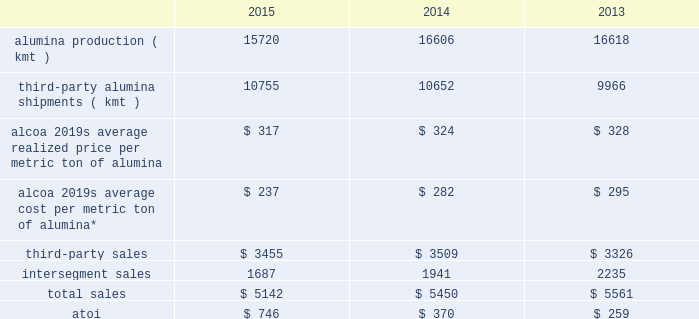Additionally , the latin american soft alloy extrusions business previously included in corporate was moved into the new transportation and construction solutions segment .
The remaining engineered products and solutions segment consists of the alcoa fastening systems and rings ( renamed to include portions of the firth rixson business acquired in november 2014 ) , alcoa power and propulsion ( includes the tital business acquired in march 2015 ) , alcoa forgings and extrusions ( includes the other portions of firth rixson ) , and alcoa titanium and engineered products ( a new business unit that consists solely of the rti international metals business acquired in july 2015 ) business units .
Segment information for all prior periods presented was updated to reflect the new segment structure .
Atoi for all reportable segments totaled $ 1906 in 2015 , $ 1968 in 2014 , and $ 1267 in 2013 .
The following information provides shipments , sales , and atoi data for each reportable segment , as well as certain production , realized price , and average cost data , for each of the three years in the period ended december 31 , 2015 .
See note q to the consolidated financial statements in part ii item 8 of this form 10-k for additional information .
Alumina .
* includes all production-related costs , including raw materials consumed ; conversion costs , such as labor , materials , and utilities ; depreciation , depletion , and amortization ; and plant administrative expenses .
This segment represents a portion of alcoa 2019s upstream operations and consists of the company 2019s worldwide refining system .
Alumina mines bauxite , from which alumina is produced and then sold directly to external smelter customers , as well as to the primary metals segment ( see primary metals below ) , or to customers who process it into industrial chemical products .
More than half of alumina 2019s production is sold under supply contracts to third parties worldwide , while the remainder is used internally by the primary metals segment .
Alumina produced by this segment and used internally is transferred to the primary metals segment at prevailing market prices .
A portion of this segment 2019s third- party sales are completed through the use of agents , alumina traders , and distributors .
Generally , the sales of this segment are transacted in u.s .
Dollars while costs and expenses of this segment are transacted in the local currency of the respective operations , which are the australian dollar , the brazilian real , the u.s .
Dollar , and the euro .
Awac is an unincorporated global joint venture between alcoa and alumina limited and consists of a number of affiliated operating entities , which own , or have an interest in , or operate the bauxite mines and alumina refineries within the alumina segment ( except for the poc 0327os de caldas refinery in brazil and a portion of the sa 0303o lul 0301s refinery in brazil ) .
Alcoa owns 60% ( 60 % ) and alumina limited owns 40% ( 40 % ) of these individual entities , which are consolidated by the company for financial reporting purposes .
As such , the results and analysis presented for the alumina segment are inclusive of alumina limited 2019s 40% ( 40 % ) interest .
In december 2014 , awac completed the sale of its ownership stake in jamalco , a bauxite mine and alumina refinery joint venture in jamaica , to noble group ltd .
Jamalco was 55% ( 55 % ) owned by a subsidiary of awac , and , while owned by awac , 55% ( 55 % ) of both the operating results and assets and liabilities of this joint venture were included in the alumina segment .
As it relates to awac 2019s previous 55% ( 55 % ) ownership stake , the refinery ( awac 2019s share of the capacity was 779 kmt-per-year ) generated sales ( third-party and intersegment ) of approximately $ 200 in 2013 , and the refinery and mine combined , at the time of divestiture , had approximately 500 employees .
See restructuring and other charges in results of operations above. .
What is the decrease in the alumina production during 2014 and 2015 , in kmt? 
Rationale: it is the variation between those two production values during 2015 and 2014 .
Computations: (16606 - 15720)
Answer: 886.0. 